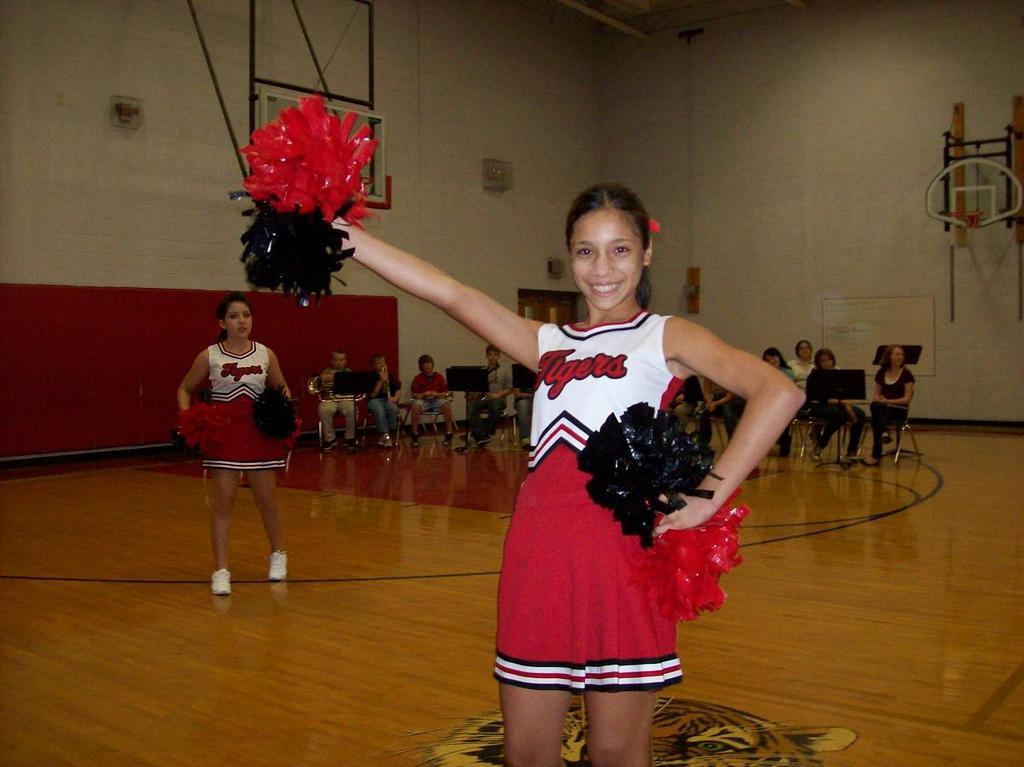<image>
Share a concise interpretation of the image provided. A cheerleader in a white and red Flyers uniform. 